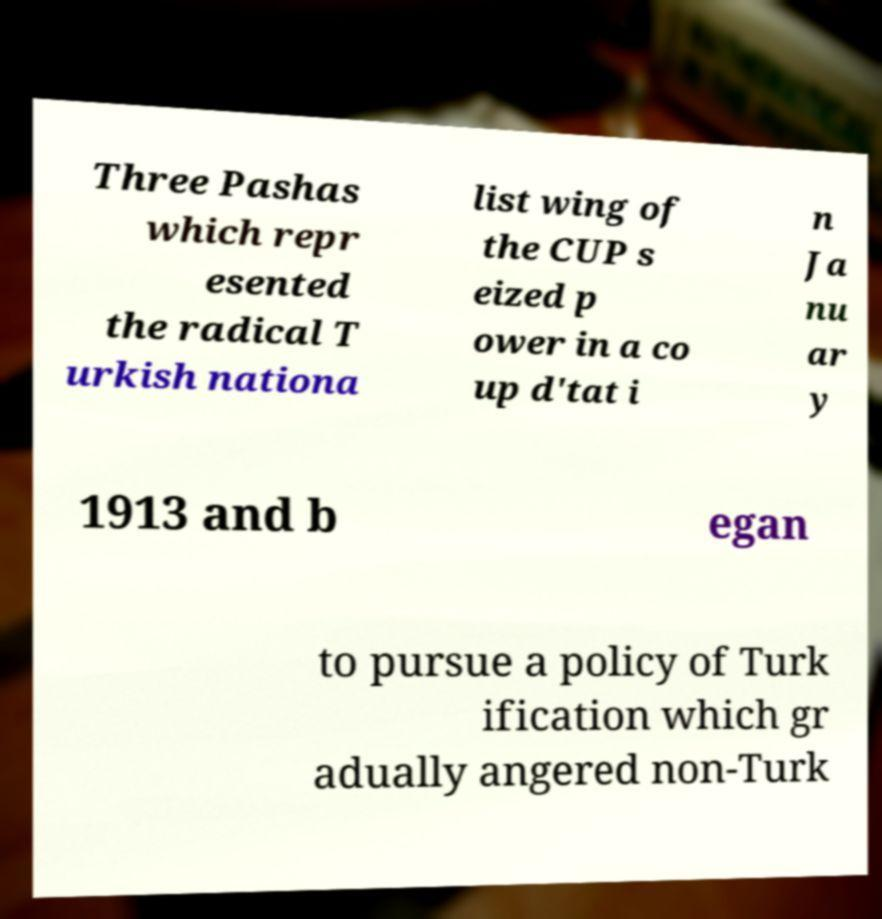Can you read and provide the text displayed in the image?This photo seems to have some interesting text. Can you extract and type it out for me? Three Pashas which repr esented the radical T urkish nationa list wing of the CUP s eized p ower in a co up d'tat i n Ja nu ar y 1913 and b egan to pursue a policy of Turk ification which gr adually angered non-Turk 